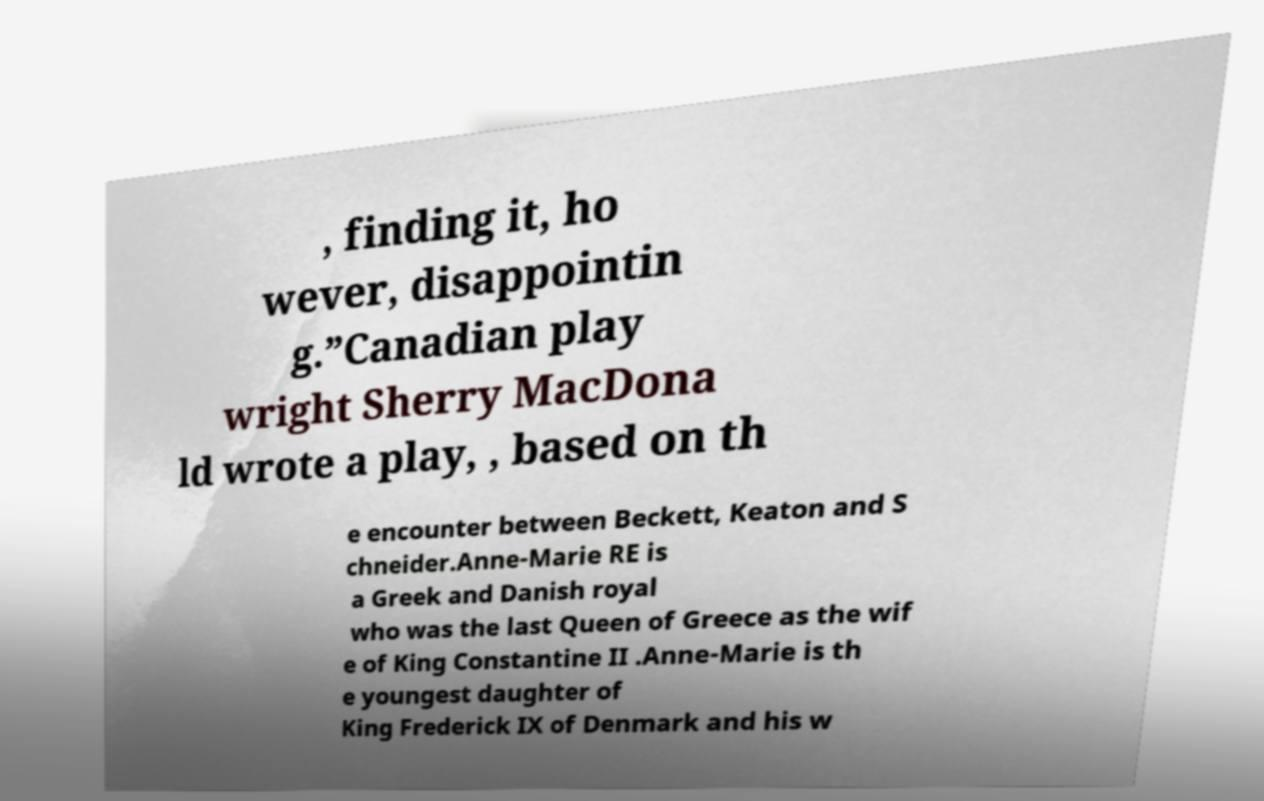I need the written content from this picture converted into text. Can you do that? , finding it, ho wever, disappointin g.”Canadian play wright Sherry MacDona ld wrote a play, , based on th e encounter between Beckett, Keaton and S chneider.Anne-Marie RE is a Greek and Danish royal who was the last Queen of Greece as the wif e of King Constantine II .Anne-Marie is th e youngest daughter of King Frederick IX of Denmark and his w 